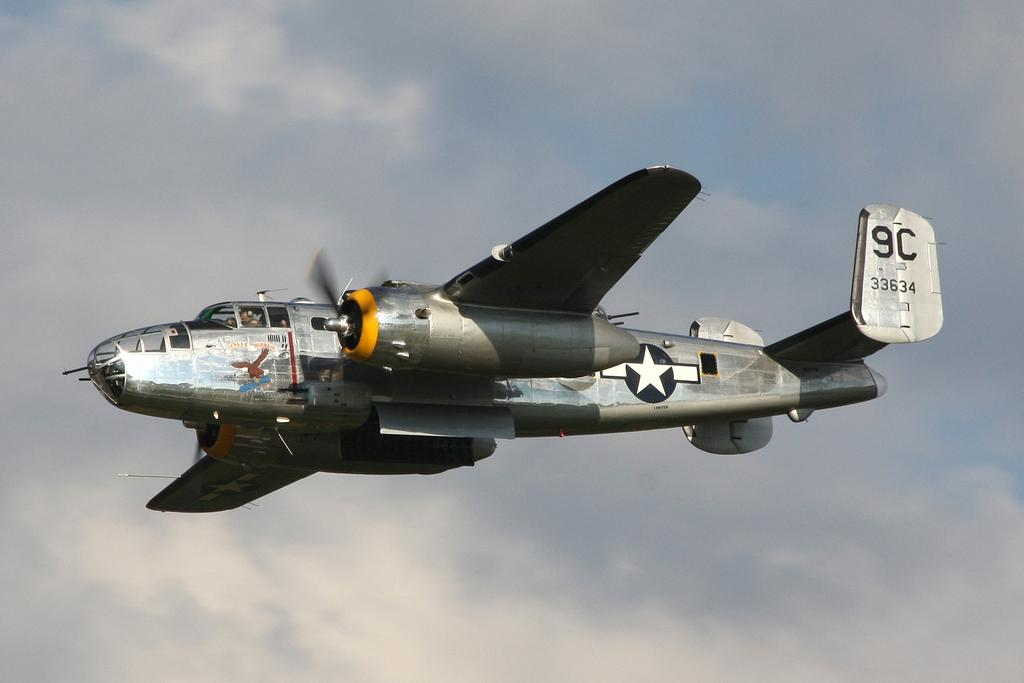What is the main subject of the picture? The main subject of the picture is a flying jet. Where is the jet located in the image? The jet is flying in the sky. How would you describe the sky in the picture? The sky is cloudy and pale blue. What is the plot of the story unfolding in the image? There is no story or plot depicted in the image; it is a picture of a flying jet in a cloudy, pale blue sky. 